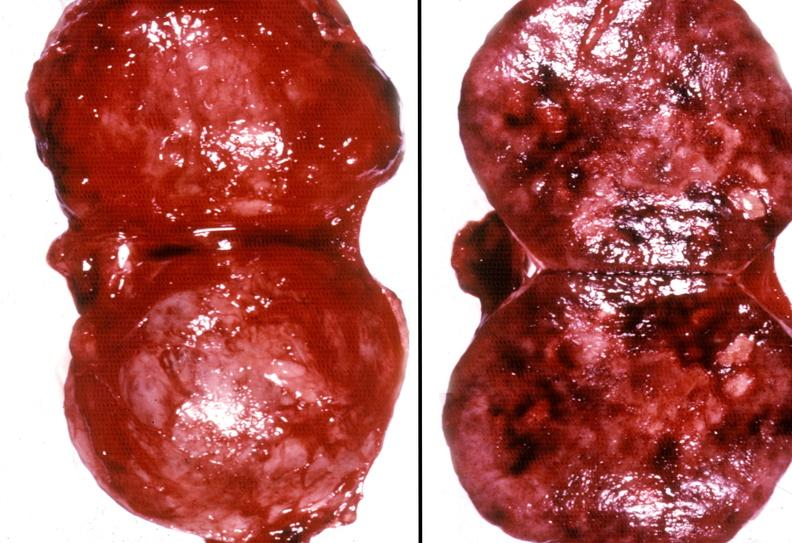s endocrine present?
Answer the question using a single word or phrase. Yes 